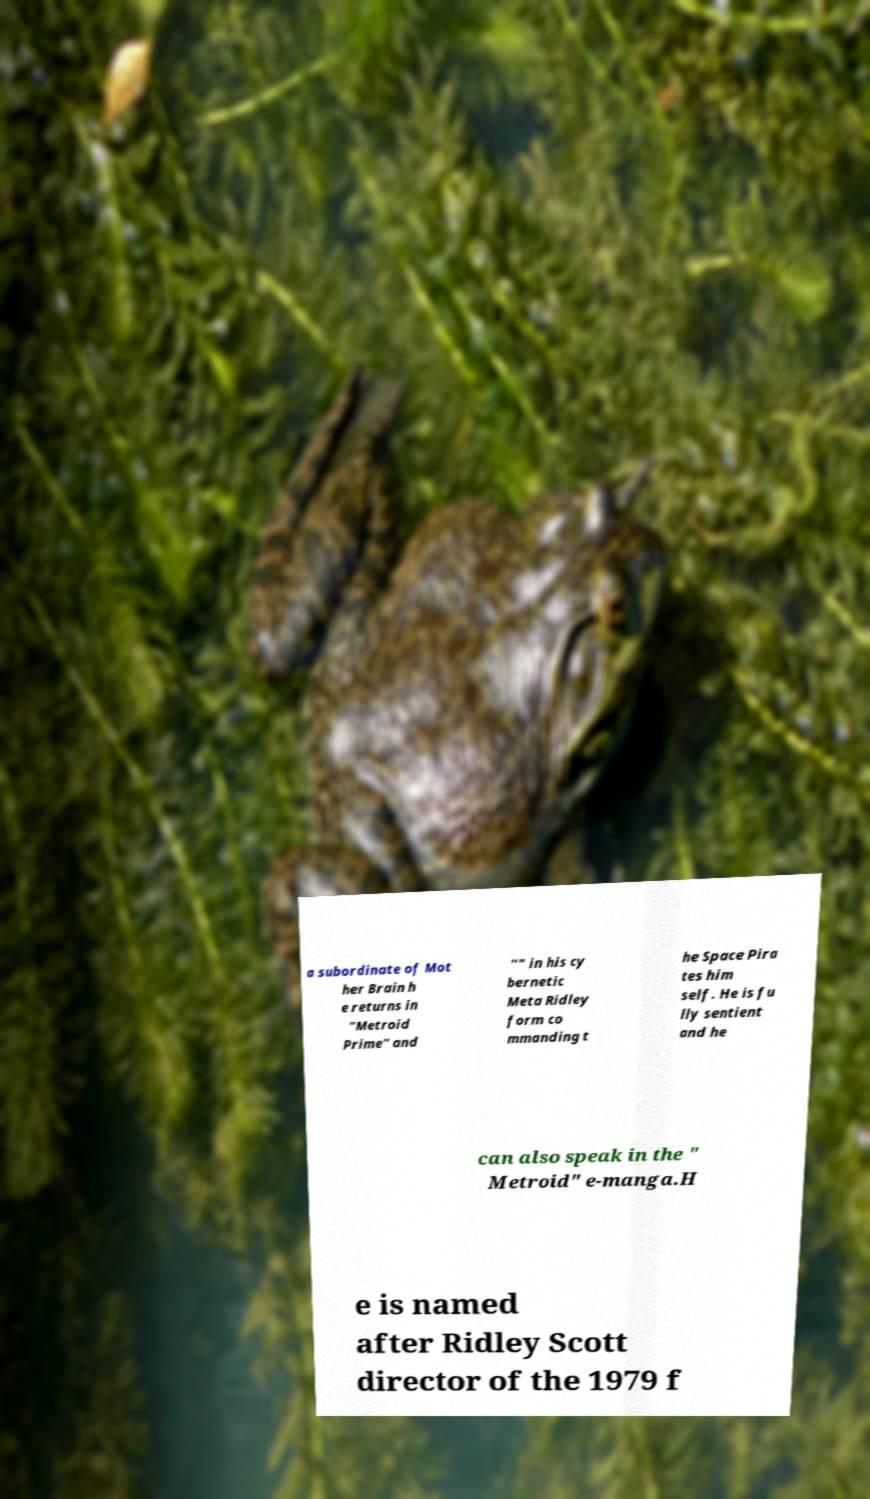Could you assist in decoding the text presented in this image and type it out clearly? a subordinate of Mot her Brain h e returns in "Metroid Prime" and "" in his cy bernetic Meta Ridley form co mmanding t he Space Pira tes him self. He is fu lly sentient and he can also speak in the " Metroid" e-manga.H e is named after Ridley Scott director of the 1979 f 